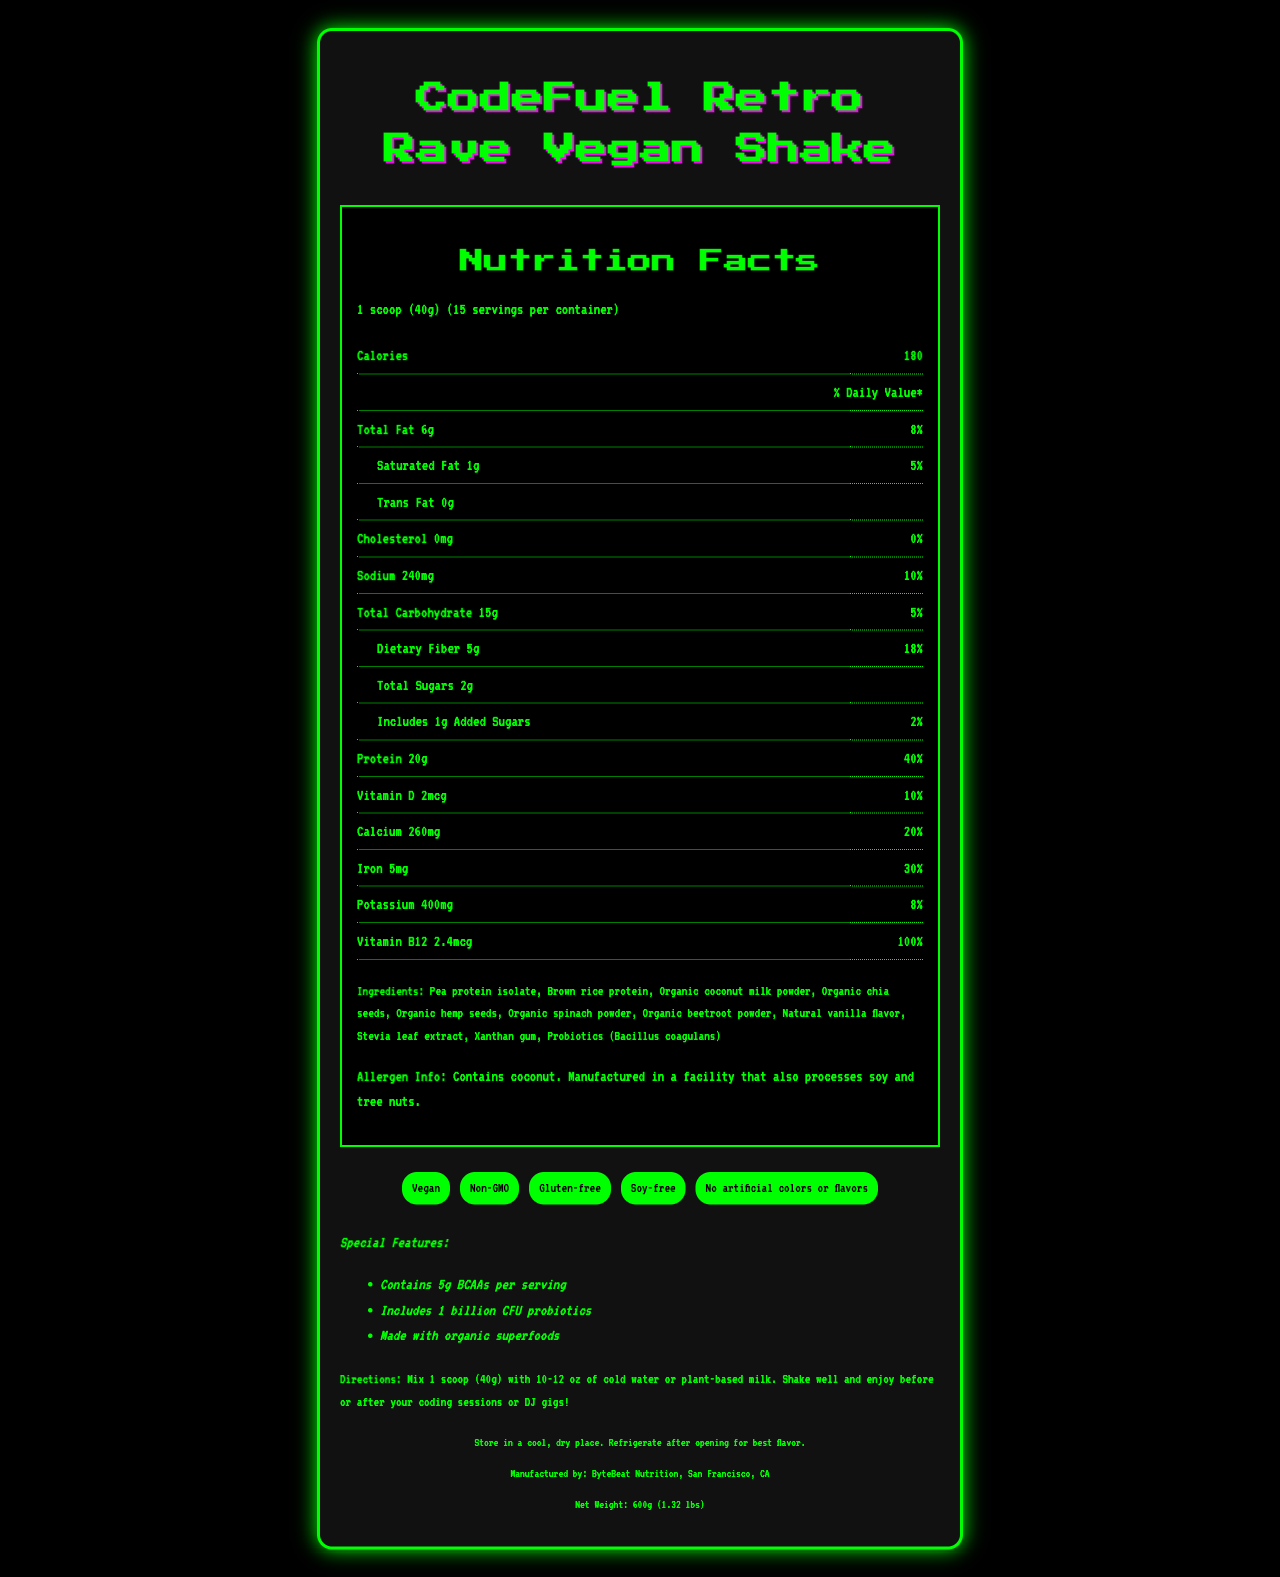What is the serving size for the CodeFuel Retro Rave Vegan Shake? The document states that the serving size is 1 scoop (40g).
Answer: 1 scoop (40g) How many servings are there per container of the shake? The document mentions that there are 15 servings per container.
Answer: 15 How much protein is in one serving? The nutrition label shows that each serving contains 20g of protein.
Answer: 20g What percentage of the daily value of Sodium is in each serving? According to the nutrition facts, each serving contains 10% of the daily value of Sodium.
Answer: 10% Which ingredient is listed first? The first listed ingredient is Pea protein isolate.
Answer: Pea protein isolate What is the total fat content per serving? The total fat content per serving is stated as 6g.
Answer: 6g How much dietary fiber is in each serving? The nutrition label shows that each serving contains 5g of dietary fiber.
Answer: 5g Is the product labeled as gluten-free? One of the claims listed on the document says the product is gluten-free.
Answer: Yes Which special feature does the shake include? 
A. Contains 10g BCAAs
B. Includes 1 billion CFU probiotics
C. Made with organic fruits
D. Contains 200mg caffeine The document mentions that one of the special features is that it includes 1 billion CFU probiotics.
Answer: B What is one of the vitamins present in the shake? 
I. Vitamin A
II. Vitamin B12
III. Vitamin C According to the nutrition facts, one of the vitamins present is Vitamin B12.
Answer: II Does the product contain any cholesterol? The nutrition label states that there is 0mg of cholesterol.
Answer: No Summarize the main idea of this document. The document details the product's nutrition facts, ingredients, allergens, special features, and usage instructions, emphasizing its benefits and suitability for a vegan diet.
Answer: The document provides comprehensive information about the CodeFuel Retro Rave Vegan Shake, covering its nutritional content, ingredients, allergen information, manufacturing details, and special features. The shake is vegan, gluten-free, and contains probiotics, BCAAs, and 20g of protein per serving. How long will the container last if I have 2 servings a day? With 15 servings per container and consuming 2 servings a day, the container will last for 15/2 = 7.5 days.
Answer: 7.5 days Who is the manufacturer of the shake? The document states that the shake is manufactured by ByteBeat Nutrition, San Francisco, CA.
Answer: ByteBeat Nutrition, San Francisco, CA Is there any information about the carbohydrate content from fiber? The document provides information on the dietary fiber content, which is 5g.
Answer: Yes What is the percentage daily value of iron in each serving? The nutrition facts show that each serving contains 30% of the daily value for iron.
Answer: 30% What are the storage instructions for the shake? The document provides these specific storage instructions.
Answer: Store in a cool, dry place. Refrigerate after opening for best flavor. Can you find out the price per container from this document? The document does not provide any information regarding the price of the product.
Answer: Cannot be determined 